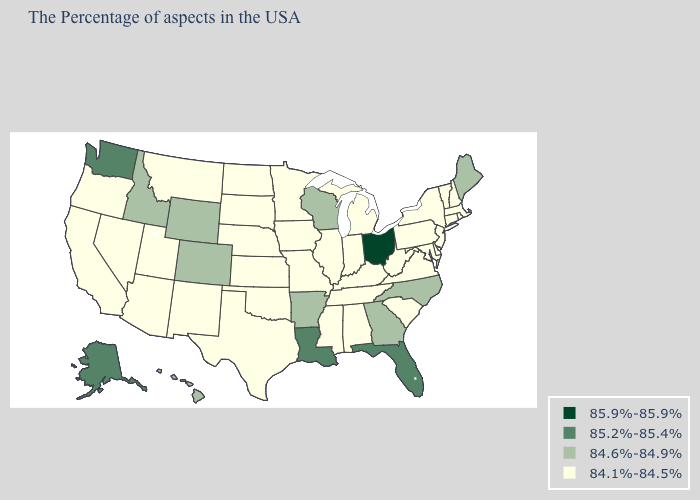What is the lowest value in the USA?
Concise answer only. 84.1%-84.5%. Name the states that have a value in the range 85.2%-85.4%?
Keep it brief. Florida, Louisiana, Washington, Alaska. What is the lowest value in the USA?
Answer briefly. 84.1%-84.5%. What is the value of New Mexico?
Short answer required. 84.1%-84.5%. Name the states that have a value in the range 84.1%-84.5%?
Answer briefly. Massachusetts, Rhode Island, New Hampshire, Vermont, Connecticut, New York, New Jersey, Delaware, Maryland, Pennsylvania, Virginia, South Carolina, West Virginia, Michigan, Kentucky, Indiana, Alabama, Tennessee, Illinois, Mississippi, Missouri, Minnesota, Iowa, Kansas, Nebraska, Oklahoma, Texas, South Dakota, North Dakota, New Mexico, Utah, Montana, Arizona, Nevada, California, Oregon. Does Michigan have the highest value in the USA?
Be succinct. No. What is the lowest value in the West?
Be succinct. 84.1%-84.5%. Name the states that have a value in the range 84.6%-84.9%?
Write a very short answer. Maine, North Carolina, Georgia, Wisconsin, Arkansas, Wyoming, Colorado, Idaho, Hawaii. What is the value of Delaware?
Answer briefly. 84.1%-84.5%. What is the highest value in the USA?
Quick response, please. 85.9%-85.9%. What is the value of Louisiana?
Answer briefly. 85.2%-85.4%. Name the states that have a value in the range 84.6%-84.9%?
Keep it brief. Maine, North Carolina, Georgia, Wisconsin, Arkansas, Wyoming, Colorado, Idaho, Hawaii. Does Missouri have the same value as Tennessee?
Be succinct. Yes. Name the states that have a value in the range 84.1%-84.5%?
Write a very short answer. Massachusetts, Rhode Island, New Hampshire, Vermont, Connecticut, New York, New Jersey, Delaware, Maryland, Pennsylvania, Virginia, South Carolina, West Virginia, Michigan, Kentucky, Indiana, Alabama, Tennessee, Illinois, Mississippi, Missouri, Minnesota, Iowa, Kansas, Nebraska, Oklahoma, Texas, South Dakota, North Dakota, New Mexico, Utah, Montana, Arizona, Nevada, California, Oregon. What is the value of Rhode Island?
Answer briefly. 84.1%-84.5%. 